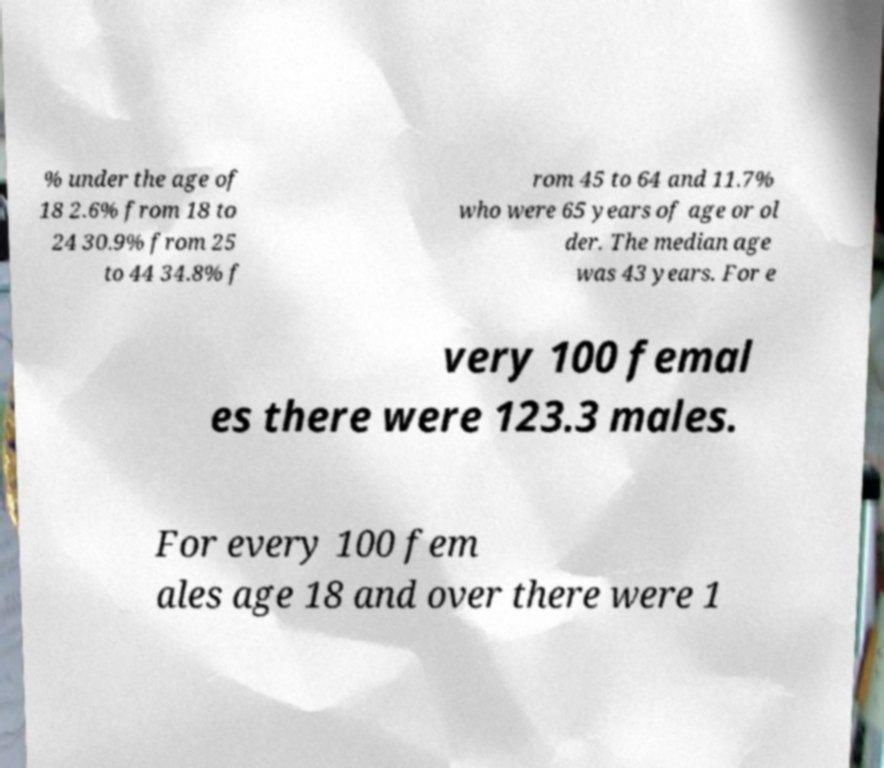I need the written content from this picture converted into text. Can you do that? % under the age of 18 2.6% from 18 to 24 30.9% from 25 to 44 34.8% f rom 45 to 64 and 11.7% who were 65 years of age or ol der. The median age was 43 years. For e very 100 femal es there were 123.3 males. For every 100 fem ales age 18 and over there were 1 